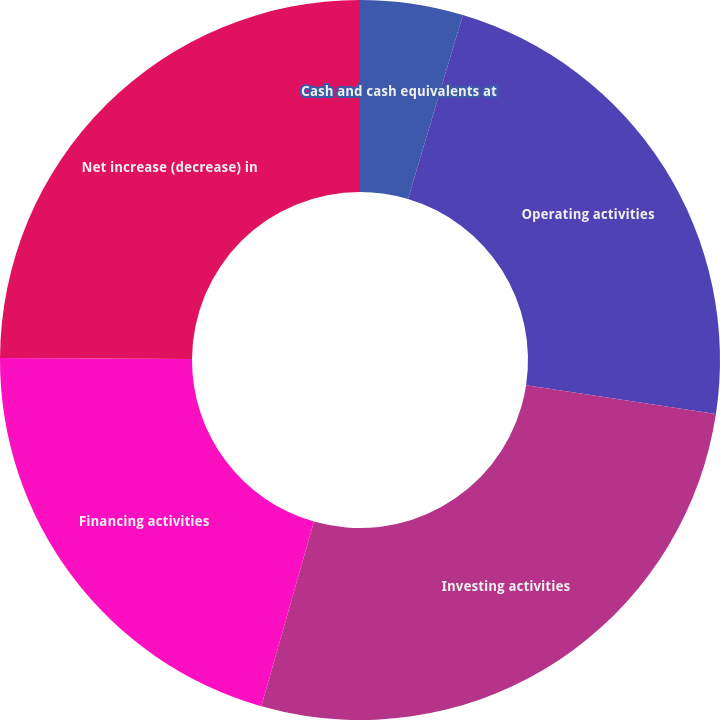Convert chart. <chart><loc_0><loc_0><loc_500><loc_500><pie_chart><fcel>Cash and cash equivalents at<fcel>Operating activities<fcel>Investing activities<fcel>Financing activities<fcel>Net increase (decrease) in<nl><fcel>4.61%<fcel>22.79%<fcel>27.02%<fcel>20.67%<fcel>24.91%<nl></chart> 